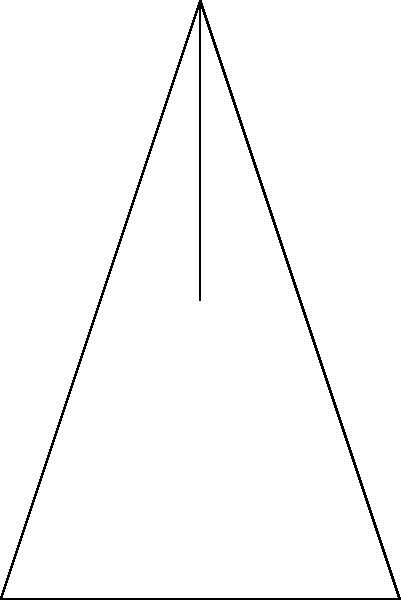During the act of genuflecting, what is the approximate angle $\theta$ formed at the knee joints, as shown in the diagram, and how does this movement demonstrate reverence in Catholic tradition? 1. Genuflecting is a physical act of reverence in Catholic tradition, typically performed before the Blessed Sacrament.

2. The diagram shows a simplified stick figure in the process of genuflecting.

3. The angle $\theta$ formed at the knee joints during genuflection is approximately 90 degrees or a right angle.

4. This angle allows for a stable, controlled lowering of the body, symbolizing humility and respect.

5. Biomechanically, this movement involves:
   a. Flexion of the knee joints
   b. Eccentric contraction of the quadriceps muscles
   c. Concentric contraction of the hamstring muscles

6. The 90-degree angle provides a balance between stability and the ability to easily return to a standing position.

7. In Catholic tradition, this physical act of lowering oneself symbolizes:
   a. Acknowledgment of God's presence in the Eucharist
   b. Submission to divine authority
   c. Humility before the Lord

8. The precise angle may vary slightly between individuals due to factors like flexibility and physical condition, but 90 degrees is a common approximation.

9. This physical act combines the spiritual significance of humbling oneself before God with the biomechanical aspects of controlled knee flexion and body lowering.
Answer: 90 degrees; symbolizes humility and reverence before God 